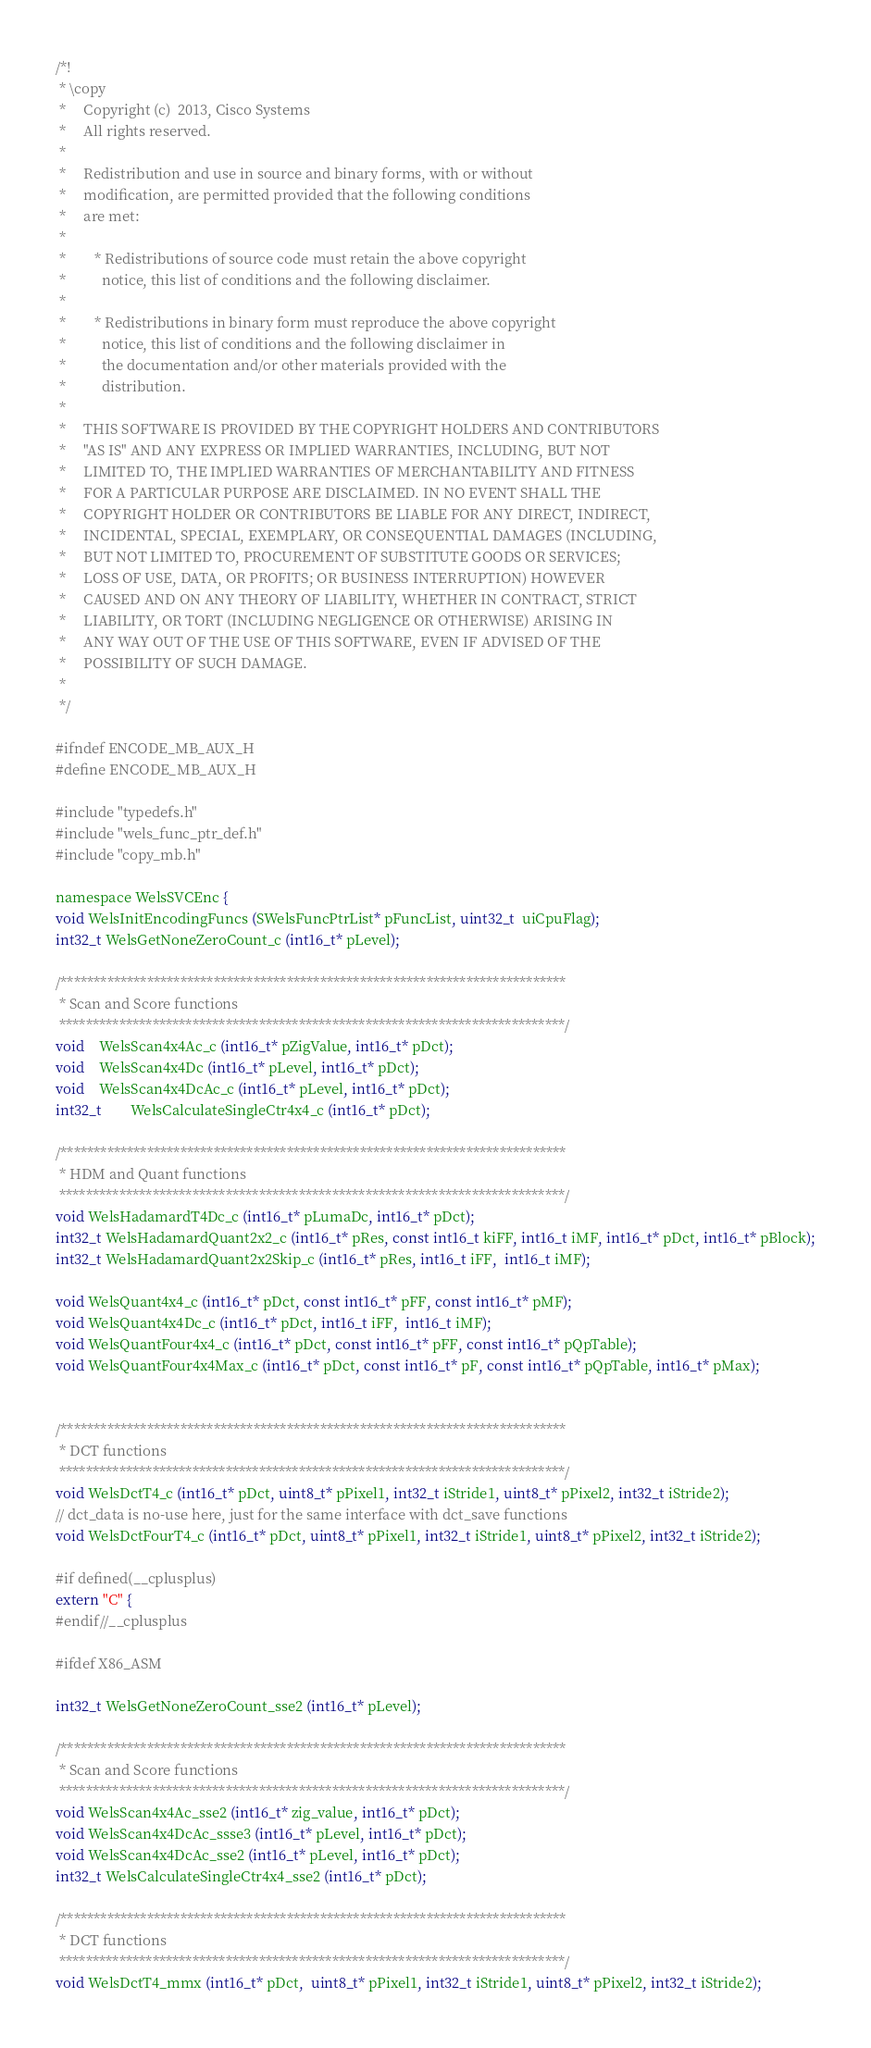<code> <loc_0><loc_0><loc_500><loc_500><_C_>/*!
 * \copy
 *     Copyright (c)  2013, Cisco Systems
 *     All rights reserved.
 *
 *     Redistribution and use in source and binary forms, with or without
 *     modification, are permitted provided that the following conditions
 *     are met:
 *
 *        * Redistributions of source code must retain the above copyright
 *          notice, this list of conditions and the following disclaimer.
 *
 *        * Redistributions in binary form must reproduce the above copyright
 *          notice, this list of conditions and the following disclaimer in
 *          the documentation and/or other materials provided with the
 *          distribution.
 *
 *     THIS SOFTWARE IS PROVIDED BY THE COPYRIGHT HOLDERS AND CONTRIBUTORS
 *     "AS IS" AND ANY EXPRESS OR IMPLIED WARRANTIES, INCLUDING, BUT NOT
 *     LIMITED TO, THE IMPLIED WARRANTIES OF MERCHANTABILITY AND FITNESS
 *     FOR A PARTICULAR PURPOSE ARE DISCLAIMED. IN NO EVENT SHALL THE
 *     COPYRIGHT HOLDER OR CONTRIBUTORS BE LIABLE FOR ANY DIRECT, INDIRECT,
 *     INCIDENTAL, SPECIAL, EXEMPLARY, OR CONSEQUENTIAL DAMAGES (INCLUDING,
 *     BUT NOT LIMITED TO, PROCUREMENT OF SUBSTITUTE GOODS OR SERVICES;
 *     LOSS OF USE, DATA, OR PROFITS; OR BUSINESS INTERRUPTION) HOWEVER
 *     CAUSED AND ON ANY THEORY OF LIABILITY, WHETHER IN CONTRACT, STRICT
 *     LIABILITY, OR TORT (INCLUDING NEGLIGENCE OR OTHERWISE) ARISING IN
 *     ANY WAY OUT OF THE USE OF THIS SOFTWARE, EVEN IF ADVISED OF THE
 *     POSSIBILITY OF SUCH DAMAGE.
 *
 */

#ifndef ENCODE_MB_AUX_H
#define ENCODE_MB_AUX_H

#include "typedefs.h"
#include "wels_func_ptr_def.h"
#include "copy_mb.h"

namespace WelsSVCEnc {
void WelsInitEncodingFuncs (SWelsFuncPtrList* pFuncList, uint32_t  uiCpuFlag);
int32_t WelsGetNoneZeroCount_c (int16_t* pLevel);

/****************************************************************************
 * Scan and Score functions
 ****************************************************************************/
void	WelsScan4x4Ac_c (int16_t* pZigValue, int16_t* pDct);
void	WelsScan4x4Dc (int16_t* pLevel, int16_t* pDct);
void	WelsScan4x4DcAc_c (int16_t* pLevel, int16_t* pDct);
int32_t		WelsCalculateSingleCtr4x4_c (int16_t* pDct);

/****************************************************************************
 * HDM and Quant functions
 ****************************************************************************/
void WelsHadamardT4Dc_c (int16_t* pLumaDc, int16_t* pDct);
int32_t WelsHadamardQuant2x2_c (int16_t* pRes, const int16_t kiFF, int16_t iMF, int16_t* pDct, int16_t* pBlock);
int32_t WelsHadamardQuant2x2Skip_c (int16_t* pRes, int16_t iFF,  int16_t iMF);

void WelsQuant4x4_c (int16_t* pDct, const int16_t* pFF, const int16_t* pMF);
void WelsQuant4x4Dc_c (int16_t* pDct, int16_t iFF,  int16_t iMF);
void WelsQuantFour4x4_c (int16_t* pDct, const int16_t* pFF, const int16_t* pQpTable);
void WelsQuantFour4x4Max_c (int16_t* pDct, const int16_t* pF, const int16_t* pQpTable, int16_t* pMax);


/****************************************************************************
 * DCT functions
 ****************************************************************************/
void WelsDctT4_c (int16_t* pDct, uint8_t* pPixel1, int32_t iStride1, uint8_t* pPixel2, int32_t iStride2);
// dct_data is no-use here, just for the same interface with dct_save functions
void WelsDctFourT4_c (int16_t* pDct, uint8_t* pPixel1, int32_t iStride1, uint8_t* pPixel2, int32_t iStride2);

#if defined(__cplusplus)
extern "C" {
#endif//__cplusplus

#ifdef X86_ASM

int32_t WelsGetNoneZeroCount_sse2 (int16_t* pLevel);

/****************************************************************************
 * Scan and Score functions
 ****************************************************************************/
void WelsScan4x4Ac_sse2 (int16_t* zig_value, int16_t* pDct);
void WelsScan4x4DcAc_ssse3 (int16_t* pLevel, int16_t* pDct);
void WelsScan4x4DcAc_sse2 (int16_t* pLevel, int16_t* pDct);
int32_t WelsCalculateSingleCtr4x4_sse2 (int16_t* pDct);

/****************************************************************************
 * DCT functions
 ****************************************************************************/
void WelsDctT4_mmx (int16_t* pDct,  uint8_t* pPixel1, int32_t iStride1, uint8_t* pPixel2, int32_t iStride2);</code> 